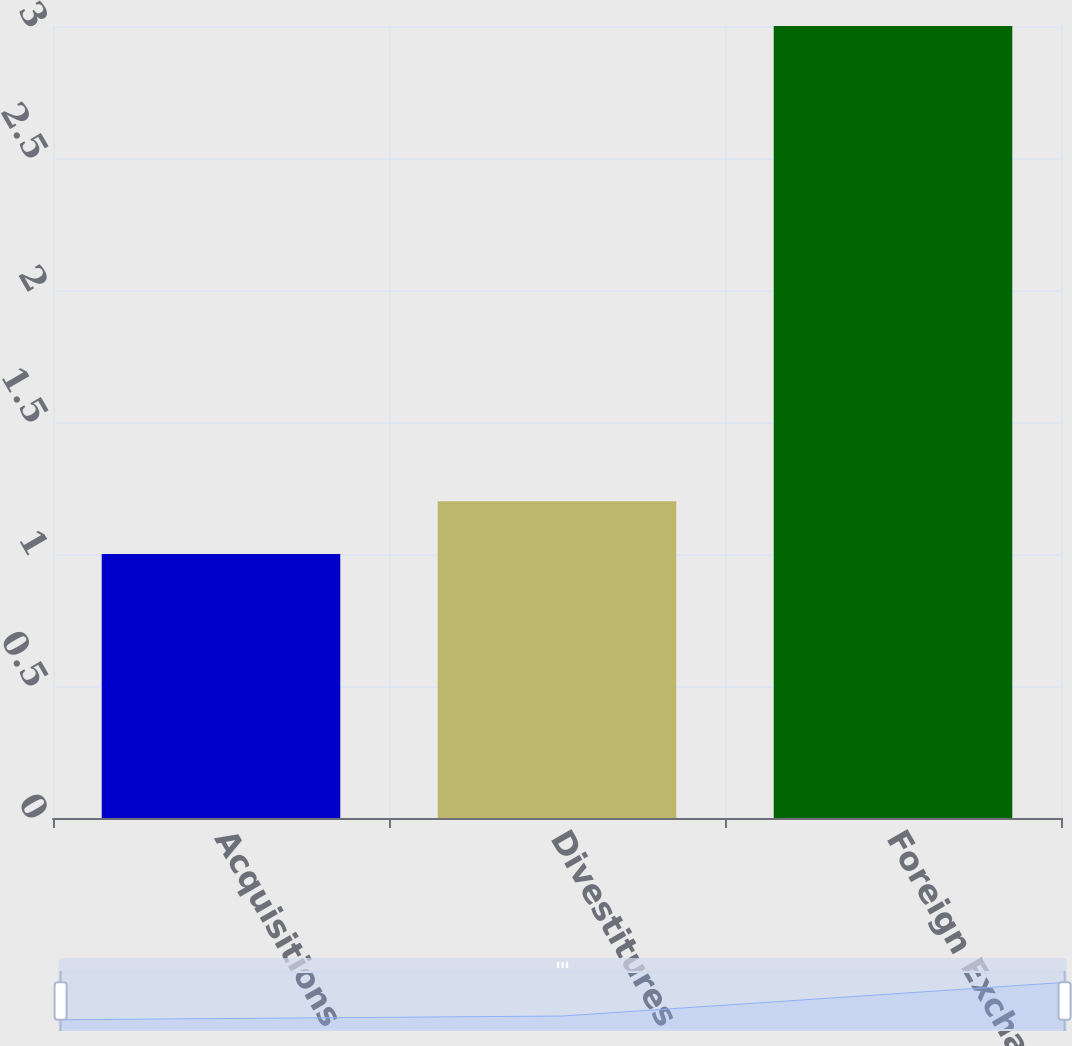<chart> <loc_0><loc_0><loc_500><loc_500><bar_chart><fcel>Acquisitions<fcel>Divestitures<fcel>Foreign Exchange<nl><fcel>1<fcel>1.2<fcel>3<nl></chart> 